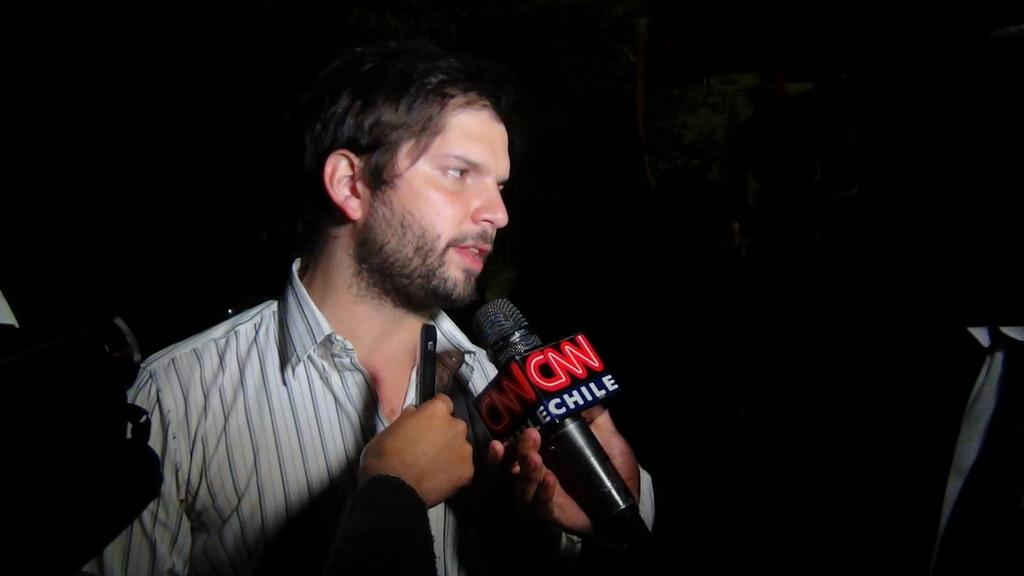What is the main subject of the image? There is a person standing in the image. What object is visible near the person? There is a microphone in the image. Is the person riding a bike down a slope in the image? No, there is no bike or slope present in the image. The image only shows a person standing with a microphone nearby. 